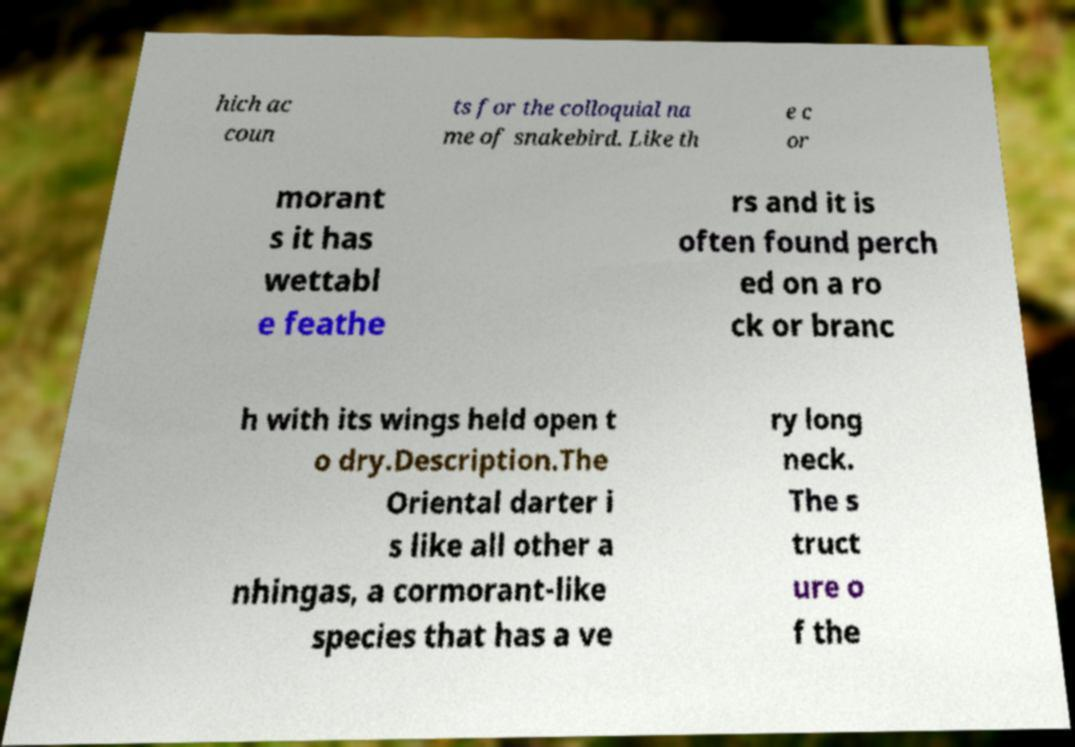Please identify and transcribe the text found in this image. hich ac coun ts for the colloquial na me of snakebird. Like th e c or morant s it has wettabl e feathe rs and it is often found perch ed on a ro ck or branc h with its wings held open t o dry.Description.The Oriental darter i s like all other a nhingas, a cormorant-like species that has a ve ry long neck. The s truct ure o f the 